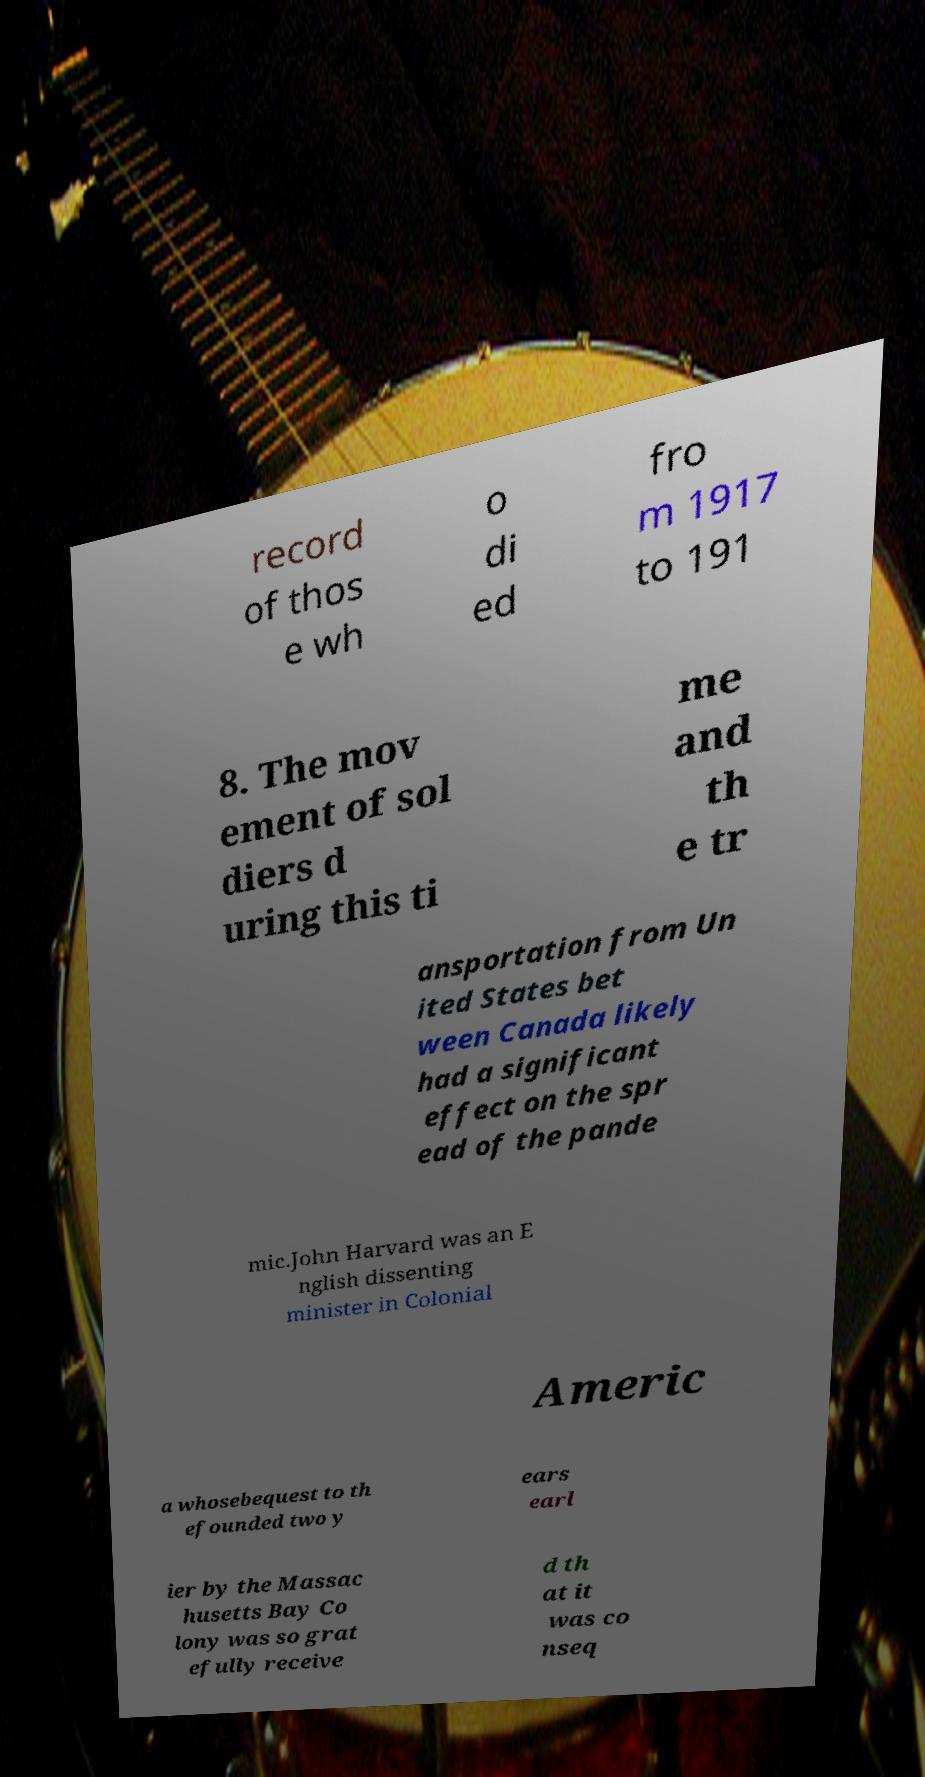Please identify and transcribe the text found in this image. record of thos e wh o di ed fro m 1917 to 191 8. The mov ement of sol diers d uring this ti me and th e tr ansportation from Un ited States bet ween Canada likely had a significant effect on the spr ead of the pande mic.John Harvard was an E nglish dissenting minister in Colonial Americ a whosebequest to th efounded two y ears earl ier by the Massac husetts Bay Co lony was so grat efully receive d th at it was co nseq 